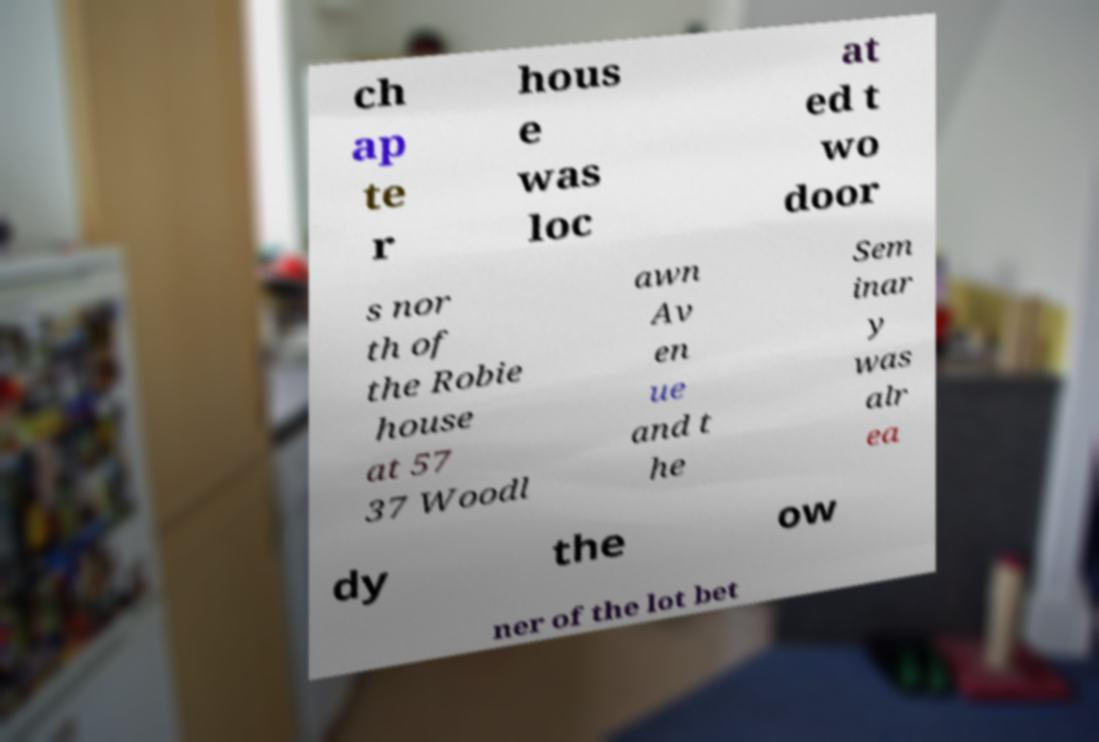For documentation purposes, I need the text within this image transcribed. Could you provide that? ch ap te r hous e was loc at ed t wo door s nor th of the Robie house at 57 37 Woodl awn Av en ue and t he Sem inar y was alr ea dy the ow ner of the lot bet 